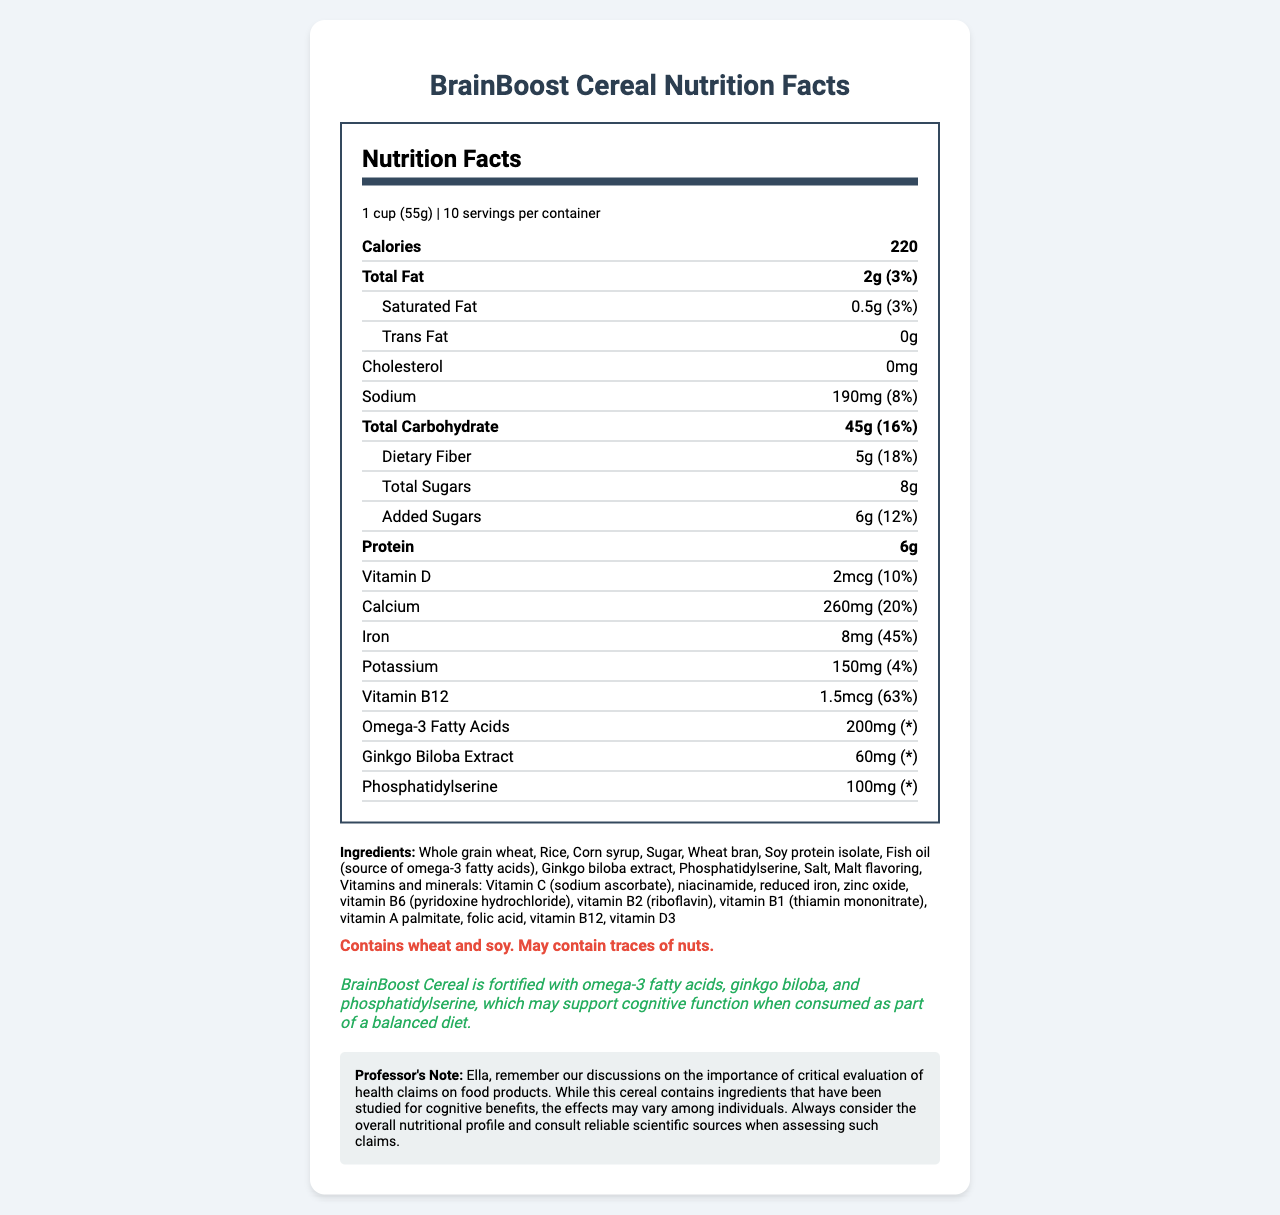what is the serving size? The serving size is mentioned right at the beginning of the nutrition facts details.
Answer: 1 cup (55g) how many calories are in one serving of BrainBoost Cereal? The calories per serving are listed prominently under the nutrition information.
Answer: 220 what is the total fat content per serving and its daily value percentage? The total fat content is listed as 2g, and the daily value percentage is shown as 3%.
Answer: 2g (3%) how much protein does one serving provide? The amount of protein per serving is specified as 6g in the nutrition section.
Answer: 6g what are the main ingredients in BrainBoost Cereal? The ingredients list is found under the ingredients section.
Answer: Whole grain wheat, Rice, Corn syrup, Sugar, Wheat bran, Soy protein isolate, Fish oil, Ginkgo biloba extract, Phosphatidylserine, Salt, Malt flavoring, Vitamins and minerals. does the cereal contain any allergens? If yes, what are they? The allergen information section clearly states that the product contains wheat and soy and may contain traces of nuts.
Answer: Yes, it contains wheat and soy. It may also contain traces of nuts. What percentage of the daily value of iron does one serving provide? The document states that one serving of BrainBoost Cereal provides 45% of the daily value of iron.
Answer: 45% how much dietary fiber is in one serving and what is its daily value percentage? The dietary fiber content per serving is 5g, with a daily value percentage of 18%.
Answer: 5g (18%) does the cereal contain any cholesterol? The nutrition facts list cholesterol as 0mg, indicating there is no cholesterol in the cereal.
Answer: No which ingredient is the main source of omega-3 fatty acids in this cereal? A. Soy protein isolate B. Fish oil C. Ginkgo biloba extract D. Phosphatidylserine Fish oil is mentioned as the source of omega-3 fatty acids in the ingredients list.
Answer: B. Fish oil what is the sodium content and its daily value percentage per serving? A. 150mg (5%) B. 190mg (8%) C. 200mg (10%) D. 170mg (7%) The sodium content per serving is 190mg, which corresponds to 8% of the daily value.
Answer: B. 190mg (8%) the health claim states that the cereal may support cognitive function when consumed as part of a balanced diet. This statement is found in the health claim section of the document.
Answer: True summarize the key nutritional information provided by the document. This comprehensive summary captures the key nutritional facts, ingredients, allergen information, and health claim about BrainBoost Cereal as presented in the document.
Answer: The document provides nutritional information for BrainBoost Cereal. One serving (1 cup or 55g) contains 220 calories, 2g of total fat (3% DV), 5g of dietary fiber (18% DV), 8g of total sugars (including 6g of added sugars, 12% DV), 6g of protein, and various vitamins and minerals like 45% DV of iron and 63% DV of vitamin B12. Ingredients include whole grains, soy protein isolate, fish oil, ginkgo biloba extract, and phosphatidylserine. The cereal contains wheat and soy, with a potential trace of nuts, and claims to support cognitive function. what effect does the cereal have on weight loss? The document does not provide any information regarding the effect of the cereal on weight loss. Only cognitive function support is mentioned.
Answer: Not enough information 